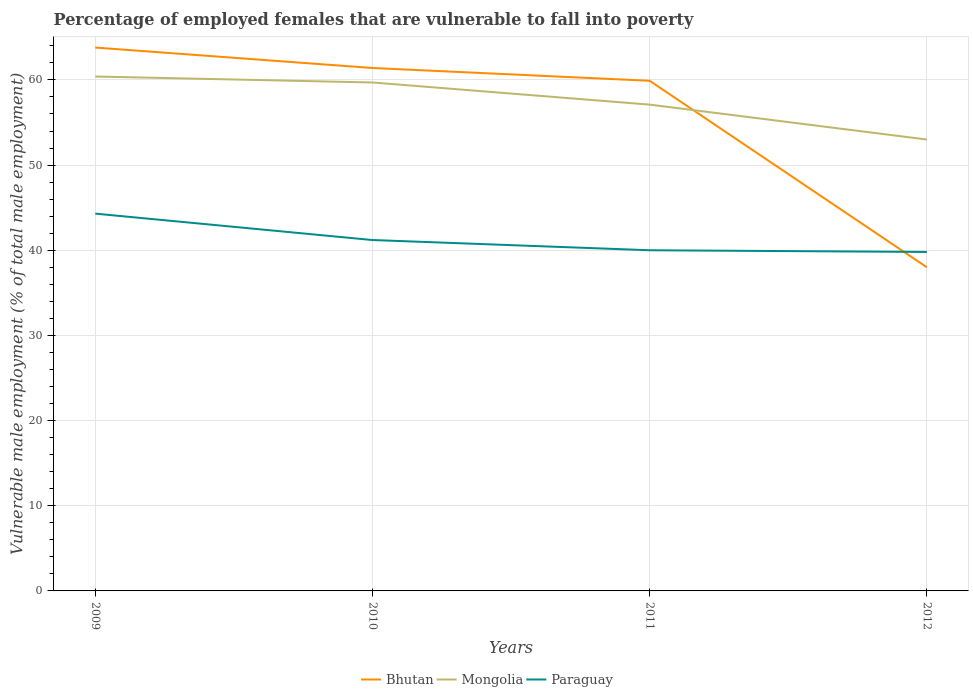How many different coloured lines are there?
Provide a short and direct response. 3. Does the line corresponding to Mongolia intersect with the line corresponding to Bhutan?
Offer a very short reply. Yes. Across all years, what is the maximum percentage of employed females who are vulnerable to fall into poverty in Mongolia?
Your answer should be compact. 53. What is the total percentage of employed females who are vulnerable to fall into poverty in Bhutan in the graph?
Offer a very short reply. 3.9. What is the difference between the highest and the second highest percentage of employed females who are vulnerable to fall into poverty in Paraguay?
Offer a terse response. 4.5. Is the percentage of employed females who are vulnerable to fall into poverty in Bhutan strictly greater than the percentage of employed females who are vulnerable to fall into poverty in Mongolia over the years?
Provide a succinct answer. No. How many years are there in the graph?
Your answer should be very brief. 4. Are the values on the major ticks of Y-axis written in scientific E-notation?
Ensure brevity in your answer.  No. Does the graph contain any zero values?
Give a very brief answer. No. Does the graph contain grids?
Provide a short and direct response. Yes. How many legend labels are there?
Your answer should be compact. 3. What is the title of the graph?
Provide a succinct answer. Percentage of employed females that are vulnerable to fall into poverty. What is the label or title of the Y-axis?
Provide a succinct answer. Vulnerable male employment (% of total male employment). What is the Vulnerable male employment (% of total male employment) in Bhutan in 2009?
Offer a very short reply. 63.8. What is the Vulnerable male employment (% of total male employment) in Mongolia in 2009?
Provide a succinct answer. 60.4. What is the Vulnerable male employment (% of total male employment) in Paraguay in 2009?
Give a very brief answer. 44.3. What is the Vulnerable male employment (% of total male employment) of Bhutan in 2010?
Offer a terse response. 61.4. What is the Vulnerable male employment (% of total male employment) of Mongolia in 2010?
Provide a succinct answer. 59.7. What is the Vulnerable male employment (% of total male employment) of Paraguay in 2010?
Provide a succinct answer. 41.2. What is the Vulnerable male employment (% of total male employment) of Bhutan in 2011?
Make the answer very short. 59.9. What is the Vulnerable male employment (% of total male employment) in Mongolia in 2011?
Keep it short and to the point. 57.1. What is the Vulnerable male employment (% of total male employment) in Paraguay in 2011?
Provide a succinct answer. 40. What is the Vulnerable male employment (% of total male employment) in Bhutan in 2012?
Your answer should be compact. 38. What is the Vulnerable male employment (% of total male employment) of Mongolia in 2012?
Your answer should be compact. 53. What is the Vulnerable male employment (% of total male employment) in Paraguay in 2012?
Offer a very short reply. 39.8. Across all years, what is the maximum Vulnerable male employment (% of total male employment) in Bhutan?
Offer a terse response. 63.8. Across all years, what is the maximum Vulnerable male employment (% of total male employment) in Mongolia?
Give a very brief answer. 60.4. Across all years, what is the maximum Vulnerable male employment (% of total male employment) of Paraguay?
Your answer should be compact. 44.3. Across all years, what is the minimum Vulnerable male employment (% of total male employment) of Bhutan?
Keep it short and to the point. 38. Across all years, what is the minimum Vulnerable male employment (% of total male employment) in Paraguay?
Your answer should be very brief. 39.8. What is the total Vulnerable male employment (% of total male employment) of Bhutan in the graph?
Make the answer very short. 223.1. What is the total Vulnerable male employment (% of total male employment) in Mongolia in the graph?
Your answer should be very brief. 230.2. What is the total Vulnerable male employment (% of total male employment) of Paraguay in the graph?
Provide a succinct answer. 165.3. What is the difference between the Vulnerable male employment (% of total male employment) of Paraguay in 2009 and that in 2010?
Keep it short and to the point. 3.1. What is the difference between the Vulnerable male employment (% of total male employment) in Mongolia in 2009 and that in 2011?
Make the answer very short. 3.3. What is the difference between the Vulnerable male employment (% of total male employment) in Paraguay in 2009 and that in 2011?
Provide a short and direct response. 4.3. What is the difference between the Vulnerable male employment (% of total male employment) of Bhutan in 2009 and that in 2012?
Offer a very short reply. 25.8. What is the difference between the Vulnerable male employment (% of total male employment) in Bhutan in 2010 and that in 2011?
Provide a short and direct response. 1.5. What is the difference between the Vulnerable male employment (% of total male employment) of Mongolia in 2010 and that in 2011?
Your answer should be very brief. 2.6. What is the difference between the Vulnerable male employment (% of total male employment) of Bhutan in 2010 and that in 2012?
Offer a terse response. 23.4. What is the difference between the Vulnerable male employment (% of total male employment) of Mongolia in 2010 and that in 2012?
Keep it short and to the point. 6.7. What is the difference between the Vulnerable male employment (% of total male employment) in Bhutan in 2011 and that in 2012?
Provide a short and direct response. 21.9. What is the difference between the Vulnerable male employment (% of total male employment) of Paraguay in 2011 and that in 2012?
Your answer should be very brief. 0.2. What is the difference between the Vulnerable male employment (% of total male employment) of Bhutan in 2009 and the Vulnerable male employment (% of total male employment) of Mongolia in 2010?
Keep it short and to the point. 4.1. What is the difference between the Vulnerable male employment (% of total male employment) in Bhutan in 2009 and the Vulnerable male employment (% of total male employment) in Paraguay in 2010?
Offer a terse response. 22.6. What is the difference between the Vulnerable male employment (% of total male employment) of Bhutan in 2009 and the Vulnerable male employment (% of total male employment) of Mongolia in 2011?
Your response must be concise. 6.7. What is the difference between the Vulnerable male employment (% of total male employment) of Bhutan in 2009 and the Vulnerable male employment (% of total male employment) of Paraguay in 2011?
Make the answer very short. 23.8. What is the difference between the Vulnerable male employment (% of total male employment) in Mongolia in 2009 and the Vulnerable male employment (% of total male employment) in Paraguay in 2011?
Provide a short and direct response. 20.4. What is the difference between the Vulnerable male employment (% of total male employment) of Bhutan in 2009 and the Vulnerable male employment (% of total male employment) of Mongolia in 2012?
Ensure brevity in your answer.  10.8. What is the difference between the Vulnerable male employment (% of total male employment) in Mongolia in 2009 and the Vulnerable male employment (% of total male employment) in Paraguay in 2012?
Give a very brief answer. 20.6. What is the difference between the Vulnerable male employment (% of total male employment) of Bhutan in 2010 and the Vulnerable male employment (% of total male employment) of Mongolia in 2011?
Offer a terse response. 4.3. What is the difference between the Vulnerable male employment (% of total male employment) in Bhutan in 2010 and the Vulnerable male employment (% of total male employment) in Paraguay in 2011?
Provide a short and direct response. 21.4. What is the difference between the Vulnerable male employment (% of total male employment) of Mongolia in 2010 and the Vulnerable male employment (% of total male employment) of Paraguay in 2011?
Make the answer very short. 19.7. What is the difference between the Vulnerable male employment (% of total male employment) in Bhutan in 2010 and the Vulnerable male employment (% of total male employment) in Paraguay in 2012?
Ensure brevity in your answer.  21.6. What is the difference between the Vulnerable male employment (% of total male employment) in Bhutan in 2011 and the Vulnerable male employment (% of total male employment) in Mongolia in 2012?
Provide a succinct answer. 6.9. What is the difference between the Vulnerable male employment (% of total male employment) of Bhutan in 2011 and the Vulnerable male employment (% of total male employment) of Paraguay in 2012?
Your answer should be very brief. 20.1. What is the average Vulnerable male employment (% of total male employment) of Bhutan per year?
Make the answer very short. 55.77. What is the average Vulnerable male employment (% of total male employment) in Mongolia per year?
Your answer should be very brief. 57.55. What is the average Vulnerable male employment (% of total male employment) of Paraguay per year?
Your response must be concise. 41.33. In the year 2009, what is the difference between the Vulnerable male employment (% of total male employment) of Bhutan and Vulnerable male employment (% of total male employment) of Paraguay?
Ensure brevity in your answer.  19.5. In the year 2010, what is the difference between the Vulnerable male employment (% of total male employment) in Bhutan and Vulnerable male employment (% of total male employment) in Paraguay?
Offer a terse response. 20.2. In the year 2011, what is the difference between the Vulnerable male employment (% of total male employment) in Bhutan and Vulnerable male employment (% of total male employment) in Paraguay?
Your answer should be very brief. 19.9. In the year 2011, what is the difference between the Vulnerable male employment (% of total male employment) of Mongolia and Vulnerable male employment (% of total male employment) of Paraguay?
Your response must be concise. 17.1. What is the ratio of the Vulnerable male employment (% of total male employment) in Bhutan in 2009 to that in 2010?
Offer a terse response. 1.04. What is the ratio of the Vulnerable male employment (% of total male employment) in Mongolia in 2009 to that in 2010?
Give a very brief answer. 1.01. What is the ratio of the Vulnerable male employment (% of total male employment) of Paraguay in 2009 to that in 2010?
Offer a terse response. 1.08. What is the ratio of the Vulnerable male employment (% of total male employment) in Bhutan in 2009 to that in 2011?
Your answer should be very brief. 1.07. What is the ratio of the Vulnerable male employment (% of total male employment) in Mongolia in 2009 to that in 2011?
Offer a very short reply. 1.06. What is the ratio of the Vulnerable male employment (% of total male employment) in Paraguay in 2009 to that in 2011?
Provide a succinct answer. 1.11. What is the ratio of the Vulnerable male employment (% of total male employment) of Bhutan in 2009 to that in 2012?
Your answer should be compact. 1.68. What is the ratio of the Vulnerable male employment (% of total male employment) in Mongolia in 2009 to that in 2012?
Offer a terse response. 1.14. What is the ratio of the Vulnerable male employment (% of total male employment) in Paraguay in 2009 to that in 2012?
Provide a short and direct response. 1.11. What is the ratio of the Vulnerable male employment (% of total male employment) of Bhutan in 2010 to that in 2011?
Offer a terse response. 1.02. What is the ratio of the Vulnerable male employment (% of total male employment) of Mongolia in 2010 to that in 2011?
Provide a succinct answer. 1.05. What is the ratio of the Vulnerable male employment (% of total male employment) of Paraguay in 2010 to that in 2011?
Ensure brevity in your answer.  1.03. What is the ratio of the Vulnerable male employment (% of total male employment) in Bhutan in 2010 to that in 2012?
Keep it short and to the point. 1.62. What is the ratio of the Vulnerable male employment (% of total male employment) of Mongolia in 2010 to that in 2012?
Ensure brevity in your answer.  1.13. What is the ratio of the Vulnerable male employment (% of total male employment) of Paraguay in 2010 to that in 2012?
Provide a succinct answer. 1.04. What is the ratio of the Vulnerable male employment (% of total male employment) of Bhutan in 2011 to that in 2012?
Your answer should be very brief. 1.58. What is the ratio of the Vulnerable male employment (% of total male employment) in Mongolia in 2011 to that in 2012?
Make the answer very short. 1.08. What is the difference between the highest and the second highest Vulnerable male employment (% of total male employment) in Paraguay?
Give a very brief answer. 3.1. What is the difference between the highest and the lowest Vulnerable male employment (% of total male employment) in Bhutan?
Offer a terse response. 25.8. What is the difference between the highest and the lowest Vulnerable male employment (% of total male employment) of Paraguay?
Give a very brief answer. 4.5. 